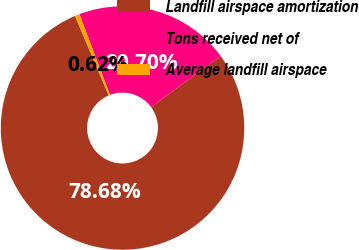Convert chart to OTSL. <chart><loc_0><loc_0><loc_500><loc_500><pie_chart><fcel>Landfill airspace amortization<fcel>Tons received net of<fcel>Average landfill airspace<nl><fcel>78.68%<fcel>20.7%<fcel>0.62%<nl></chart> 